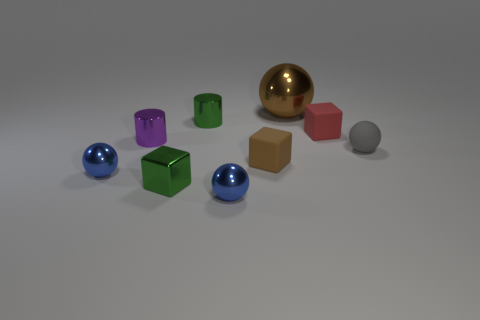Is there anything else that has the same size as the brown metallic thing?
Keep it short and to the point. No. Is the number of brown metal balls greater than the number of large red matte cylinders?
Provide a short and direct response. Yes. How many purple cylinders are there?
Your response must be concise. 1. What shape is the green object that is in front of the tiny gray rubber ball behind the blue thing right of the green shiny cylinder?
Your answer should be very brief. Cube. Are there fewer tiny brown matte things that are in front of the small brown rubber object than tiny metallic spheres that are on the left side of the big ball?
Provide a short and direct response. Yes. There is a brown object in front of the red rubber object; is it the same shape as the tiny green metallic object that is in front of the gray rubber object?
Provide a succinct answer. Yes. There is a tiny blue shiny object behind the tiny block that is on the left side of the brown rubber block; what shape is it?
Give a very brief answer. Sphere. There is a metallic cylinder that is the same color as the metal block; what is its size?
Provide a succinct answer. Small. Is there a tiny blue object made of the same material as the big brown object?
Provide a short and direct response. Yes. What material is the sphere right of the brown metallic object?
Offer a very short reply. Rubber. 